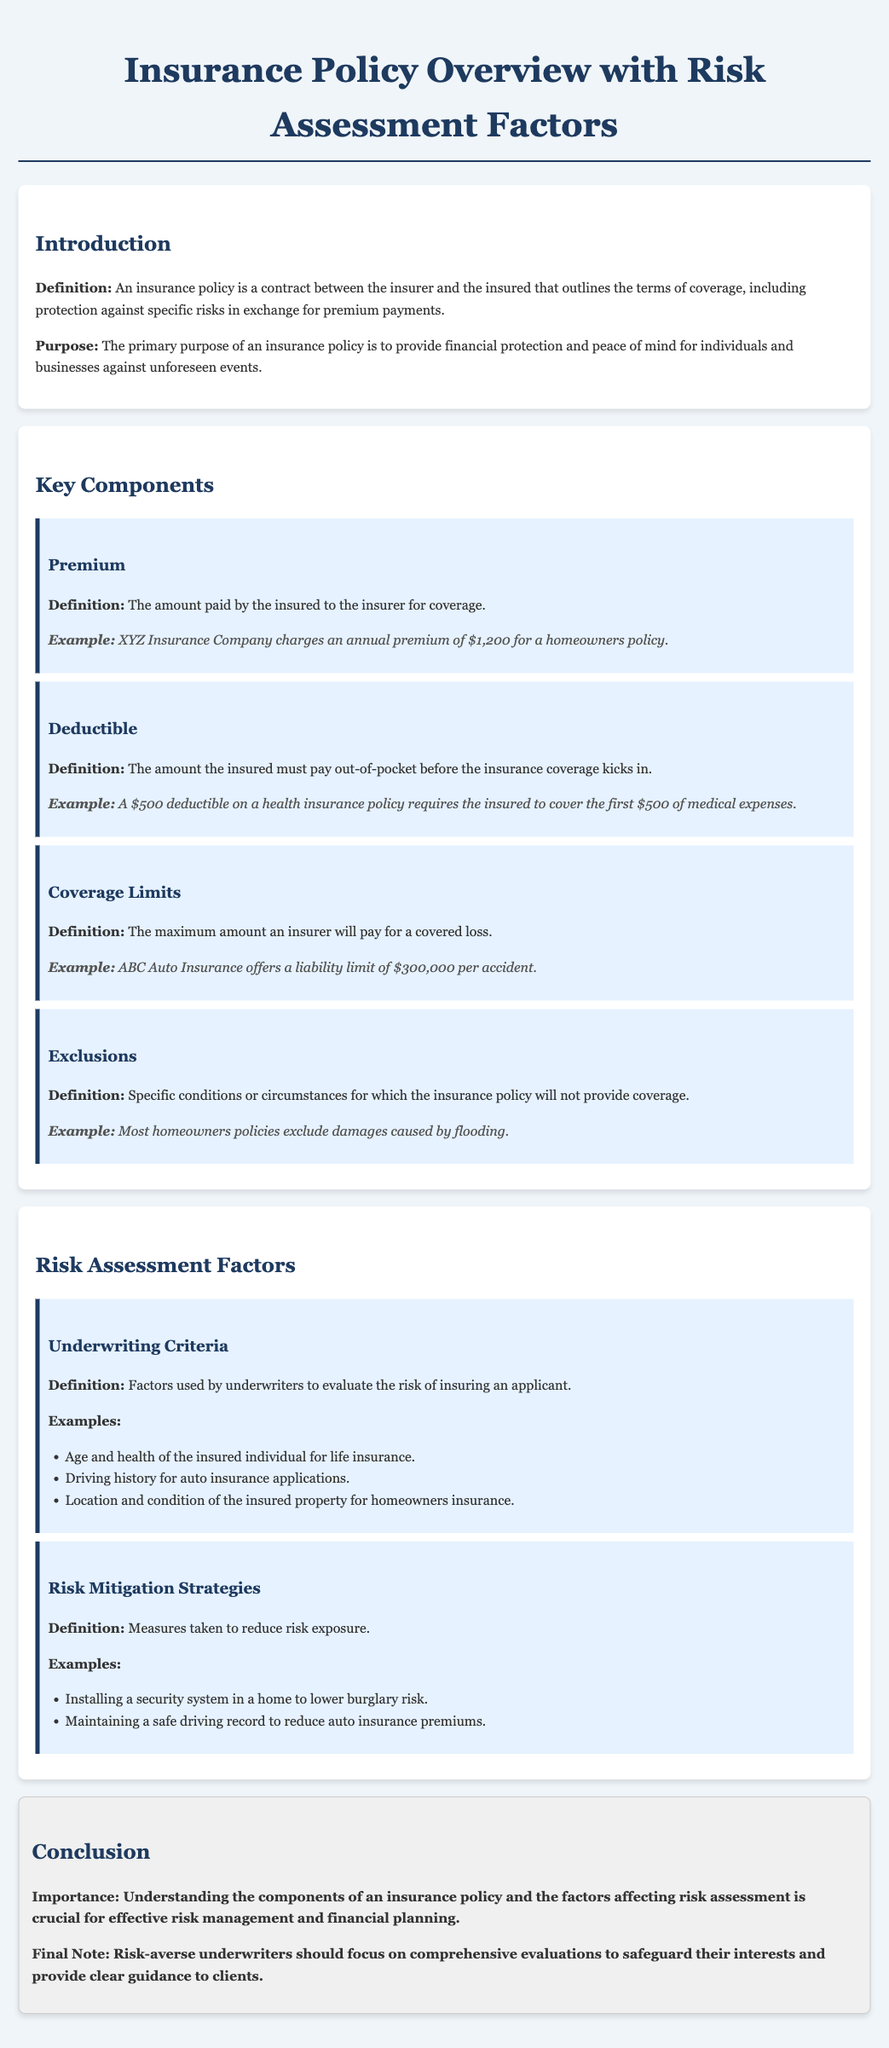What is the purpose of an insurance policy? The purpose of an insurance policy is to provide financial protection and peace of mind for individuals and businesses against unforeseen events.
Answer: financial protection and peace of mind What is a premium? A premium is the amount paid by the insured to the insurer for coverage.
Answer: amount paid for coverage What is the deductible amount in a health insurance policy example? The deductible amount is the first $500 of medical expenses that the insured must cover out-of-pocket.
Answer: $500 What are coverage limits? Coverage limits are the maximum amount an insurer will pay for a covered loss.
Answer: maximum payout What is one example of an underwriting criterion? An example of an underwriting criterion is the age and health of the insured individual for life insurance.
Answer: age and health What should risk-averse underwriters focus on? Risk-averse underwriters should focus on comprehensive evaluations to safeguard their interests and provide clear guidance to clients.
Answer: comprehensive evaluations What type of strategy involves installing a security system? Installing a security system is a risk mitigation strategy.
Answer: risk mitigation strategy How many key components are outlined in the document? The document outlines four key components.
Answer: four What is excluded in most homeowners' policies? Most homeowners' policies exclude damages caused by flooding.
Answer: damages caused by flooding 